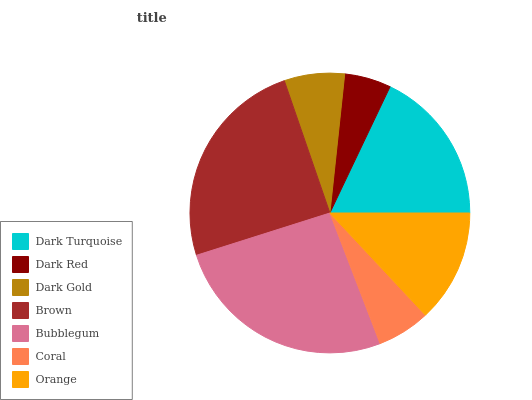Is Dark Red the minimum?
Answer yes or no. Yes. Is Bubblegum the maximum?
Answer yes or no. Yes. Is Dark Gold the minimum?
Answer yes or no. No. Is Dark Gold the maximum?
Answer yes or no. No. Is Dark Gold greater than Dark Red?
Answer yes or no. Yes. Is Dark Red less than Dark Gold?
Answer yes or no. Yes. Is Dark Red greater than Dark Gold?
Answer yes or no. No. Is Dark Gold less than Dark Red?
Answer yes or no. No. Is Orange the high median?
Answer yes or no. Yes. Is Orange the low median?
Answer yes or no. Yes. Is Brown the high median?
Answer yes or no. No. Is Dark Turquoise the low median?
Answer yes or no. No. 